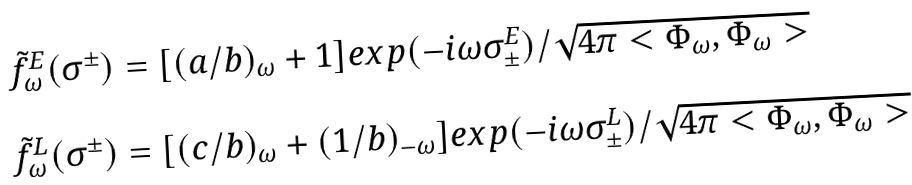Convert formula to latex. <formula><loc_0><loc_0><loc_500><loc_500>\begin{array} { l l } \tilde { f } _ { \omega } ^ { E } ( \sigma ^ { \pm } ) = [ ( a / b ) _ { \omega } + 1 ] e x p ( - i \omega { \sigma ^ { E } _ { \pm } } ) / \sqrt { 4 \pi < \Phi _ { \omega } , \Phi _ { \omega } > } \\ \\ \tilde { f } _ { \omega } ^ { L } ( \sigma ^ { \pm } ) = [ ( c / b ) _ { \omega } + ( 1 / b ) _ { - \omega } ] e x p ( - i \omega { \sigma ^ { L } _ { \pm } } ) / \sqrt { 4 \pi < \Phi _ { \omega } , \Phi _ { \omega } > } \end{array}</formula> 